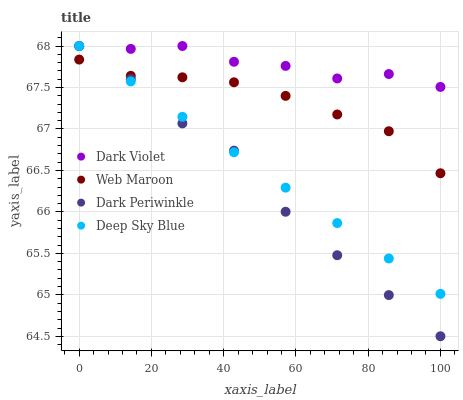Does Dark Periwinkle have the minimum area under the curve?
Answer yes or no. Yes. Does Dark Violet have the maximum area under the curve?
Answer yes or no. Yes. Does Web Maroon have the minimum area under the curve?
Answer yes or no. No. Does Web Maroon have the maximum area under the curve?
Answer yes or no. No. Is Deep Sky Blue the smoothest?
Answer yes or no. Yes. Is Dark Periwinkle the roughest?
Answer yes or no. Yes. Is Web Maroon the smoothest?
Answer yes or no. No. Is Web Maroon the roughest?
Answer yes or no. No. Does Dark Periwinkle have the lowest value?
Answer yes or no. Yes. Does Web Maroon have the lowest value?
Answer yes or no. No. Does Dark Violet have the highest value?
Answer yes or no. Yes. Does Web Maroon have the highest value?
Answer yes or no. No. Is Web Maroon less than Dark Violet?
Answer yes or no. Yes. Is Dark Violet greater than Web Maroon?
Answer yes or no. Yes. Does Deep Sky Blue intersect Dark Violet?
Answer yes or no. Yes. Is Deep Sky Blue less than Dark Violet?
Answer yes or no. No. Is Deep Sky Blue greater than Dark Violet?
Answer yes or no. No. Does Web Maroon intersect Dark Violet?
Answer yes or no. No. 